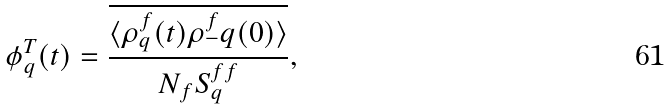<formula> <loc_0><loc_0><loc_500><loc_500>\phi ^ { T } _ { q } ( t ) = \frac { \overline { \langle \rho ^ { f } _ { q } ( t ) \rho ^ { f } _ { - } q ( 0 ) \rangle } } { N _ { f } S ^ { f f } _ { q } } ,</formula> 